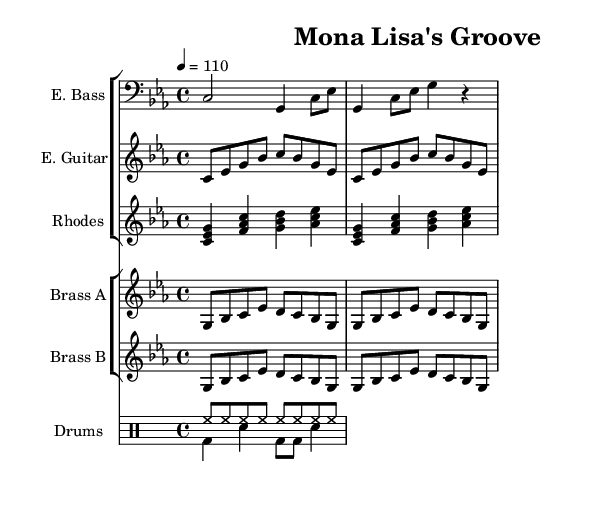What is the key signature of this music? The key signature is C minor, indicated by the three flats in the key signature area.
Answer: C minor What is the time signature of this music? The time signature is 4/4, which is shown at the beginning of the score and indicates that there are four beats in each measure.
Answer: 4/4 What is the tempo marking indicated in the score? The tempo marking is 4 = 110, meaning that the quarter note gets 110 beats per minute.
Answer: 110 How many measures are there in the electric bass part? The electric bass part consists of two measures, as seen in the notation which clearly delineates two separate groups of notes.
Answer: 2 What instruments are included in this arrangement? The arrangement includes electric bass, electric guitar, Rhodes piano, brass section A, brass section B, and drums, as seen in the staff groups and their corresponding instruments.
Answer: Electric bass, electric guitar, Rhodes piano, brass section A, brass section B, drums What type of groove is established in the drum pattern? The groove features a consistent hi-hat pattern in eighth notes and a bass drum with snare downbeats, common in funk music, which creates a danceable rhythm.
Answer: Funk groove How do the brass sections contribute to the overall feel of the piece? The brass sections play repetitive melodic phrases in eighth notes that enhance the rhythmic drive and add vibrancy, which is essential for the funk style and complements the other instruments.
Answer: Rhythmic drive 